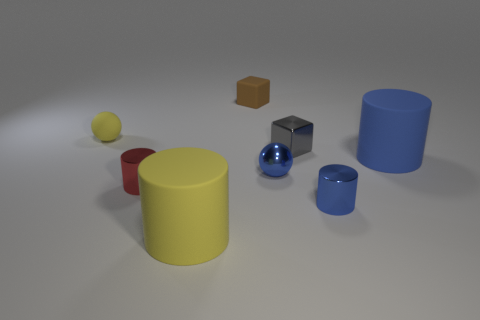Subtract all brown cubes. How many blue cylinders are left? 2 Add 2 gray blocks. How many objects exist? 10 Subtract all red metallic cylinders. How many cylinders are left? 3 Subtract 1 cylinders. How many cylinders are left? 3 Subtract all yellow cylinders. How many cylinders are left? 3 Subtract all purple cylinders. Subtract all brown blocks. How many cylinders are left? 4 Subtract all cubes. How many objects are left? 6 Subtract 0 brown cylinders. How many objects are left? 8 Subtract all big red matte cubes. Subtract all big matte cylinders. How many objects are left? 6 Add 4 gray cubes. How many gray cubes are left? 5 